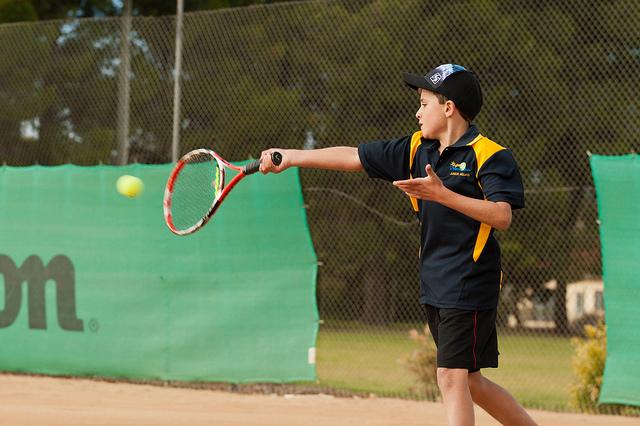What is this person holding?
Quick response, please. Tennis racket. What kind of trees are in the background?
Short answer required. Pine. Is this an adult male?
Keep it brief. No. 